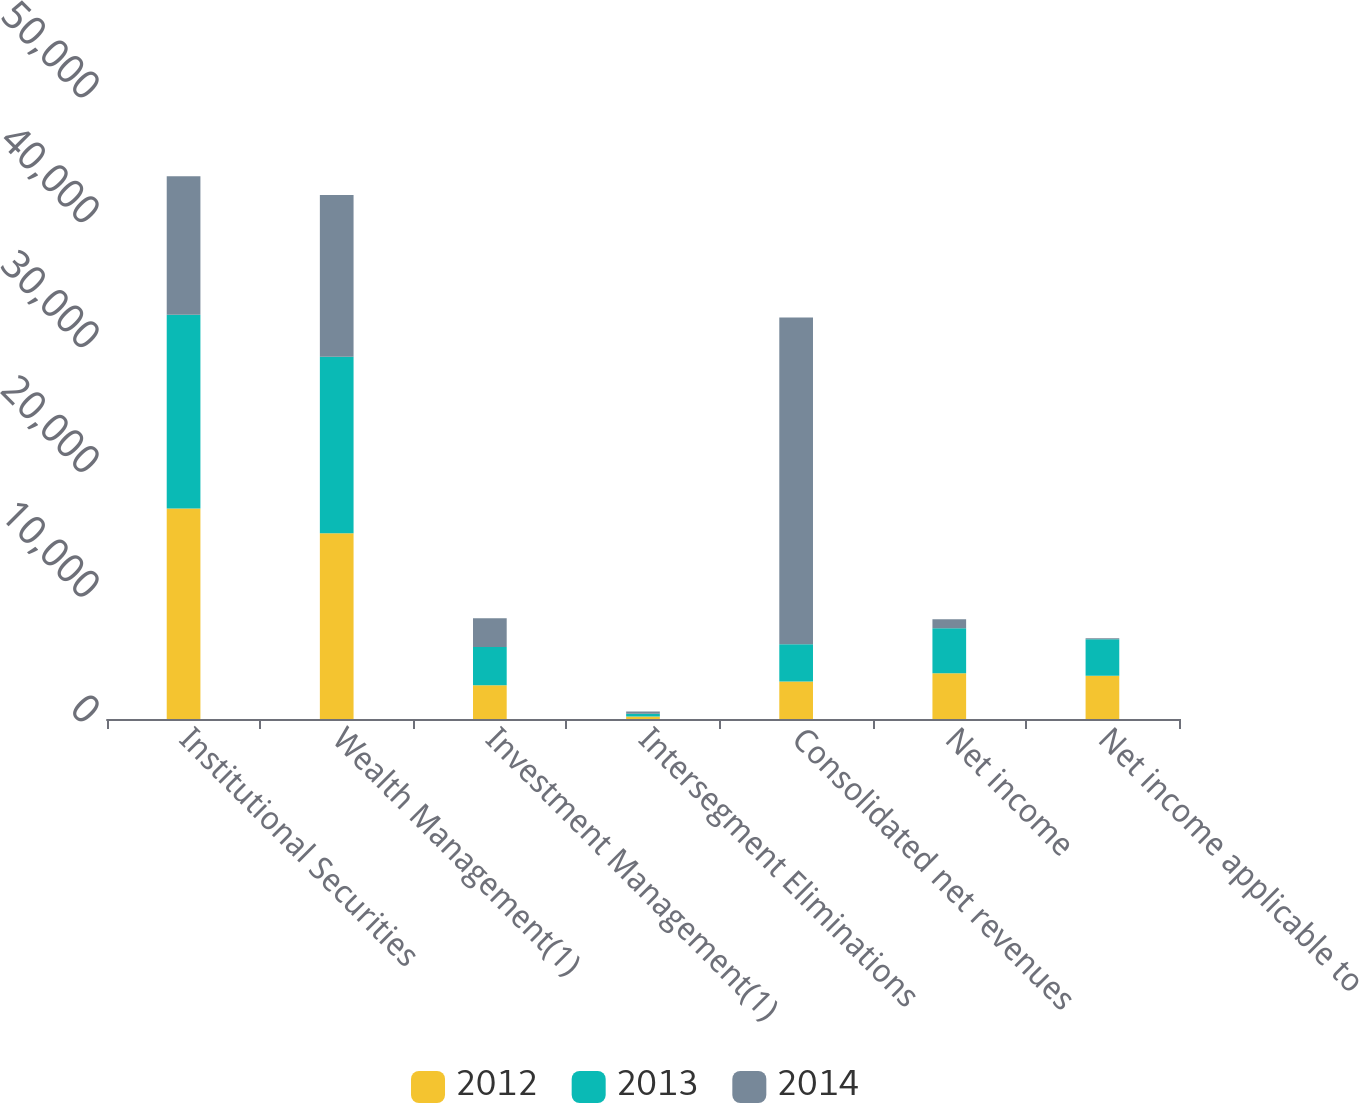Convert chart. <chart><loc_0><loc_0><loc_500><loc_500><stacked_bar_chart><ecel><fcel>Institutional Securities<fcel>Wealth Management(1)<fcel>Investment Management(1)<fcel>Intersegment Eliminations<fcel>Consolidated net revenues<fcel>Net income<fcel>Net income applicable to<nl><fcel>2012<fcel>16871<fcel>14888<fcel>2712<fcel>196<fcel>2995.5<fcel>3667<fcel>3467<nl><fcel>2013<fcel>15519<fcel>14143<fcel>3059<fcel>228<fcel>2995.5<fcel>3613<fcel>2932<nl><fcel>2014<fcel>11101<fcel>12947<fcel>2306<fcel>176<fcel>26178<fcel>716<fcel>68<nl></chart> 